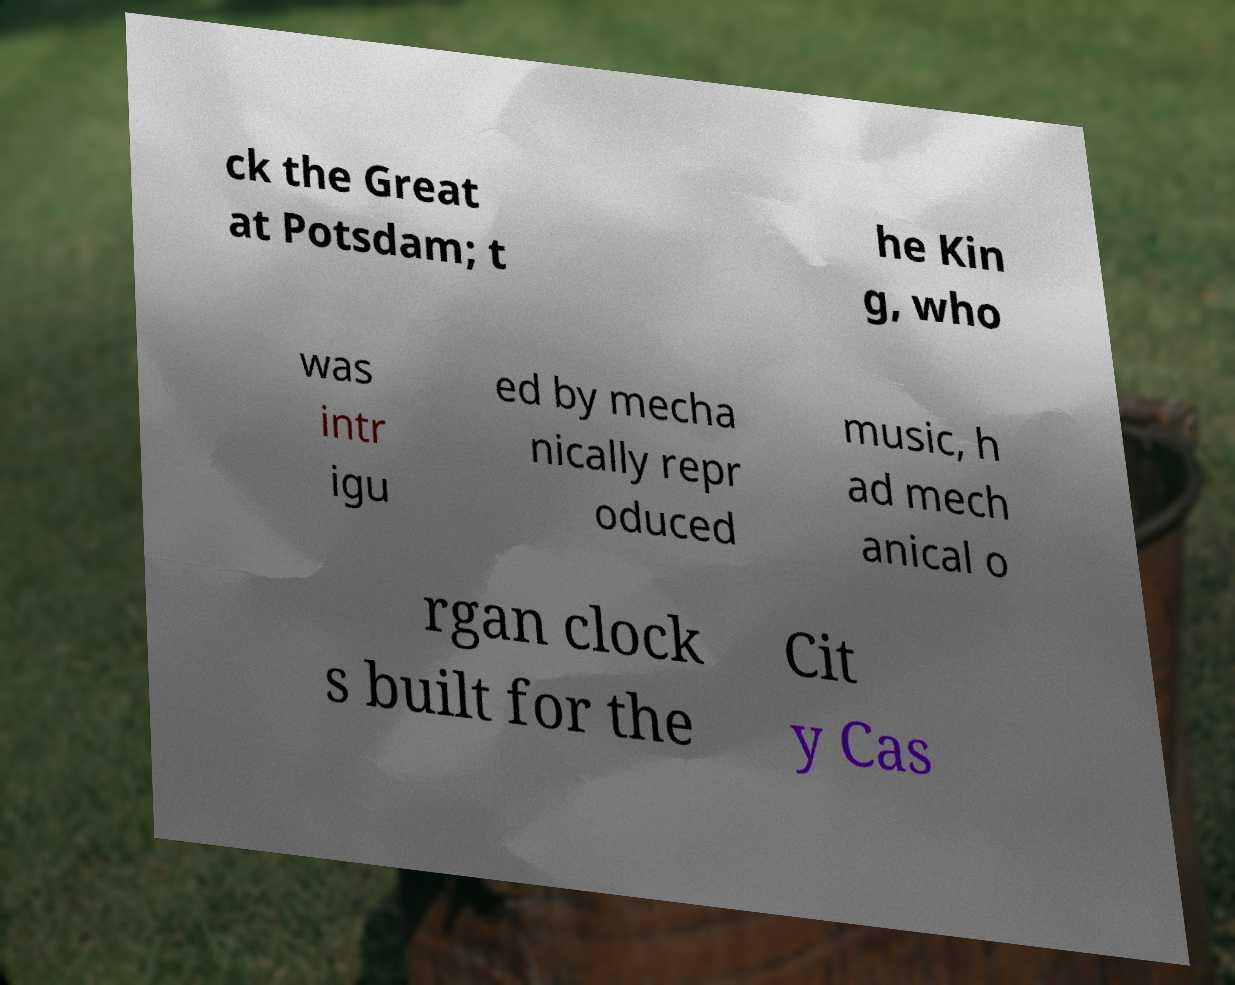Can you accurately transcribe the text from the provided image for me? ck the Great at Potsdam; t he Kin g, who was intr igu ed by mecha nically repr oduced music, h ad mech anical o rgan clock s built for the Cit y Cas 